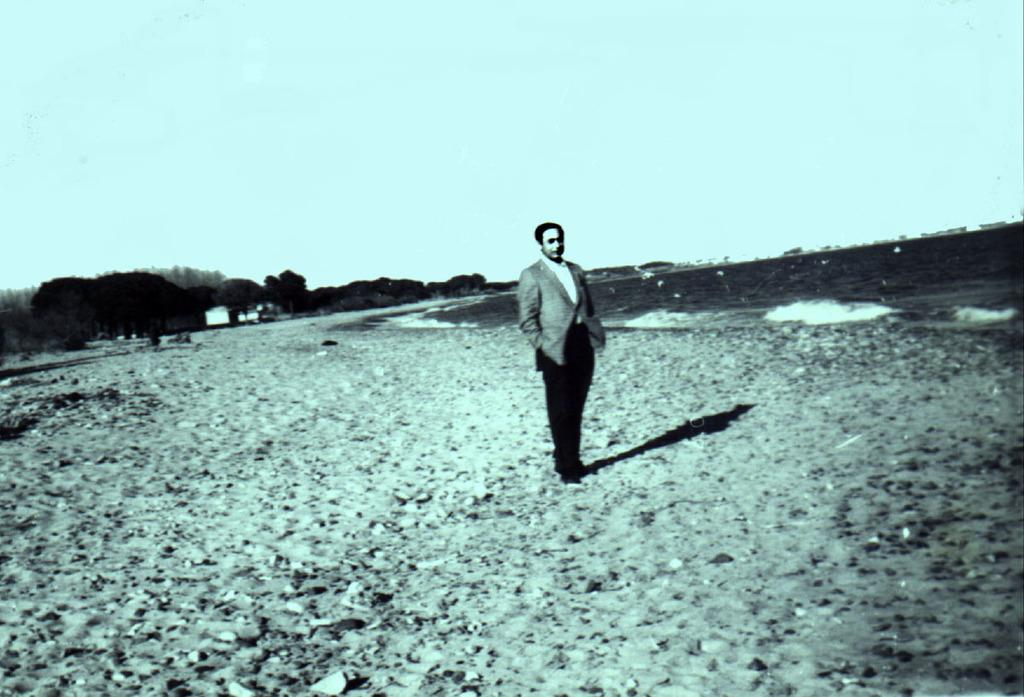What is the person in the image standing on? The person is standing on the sand surface. What is located behind the person? The person is in front of the sea. What can be seen in the background of the image? There are trees in the background of the image. What type of board is the person using to surf in the image? There is no board present in the image, and the person is not surfing. What pets can be seen accompanying the person in the image? There are no pets visible in the image. 